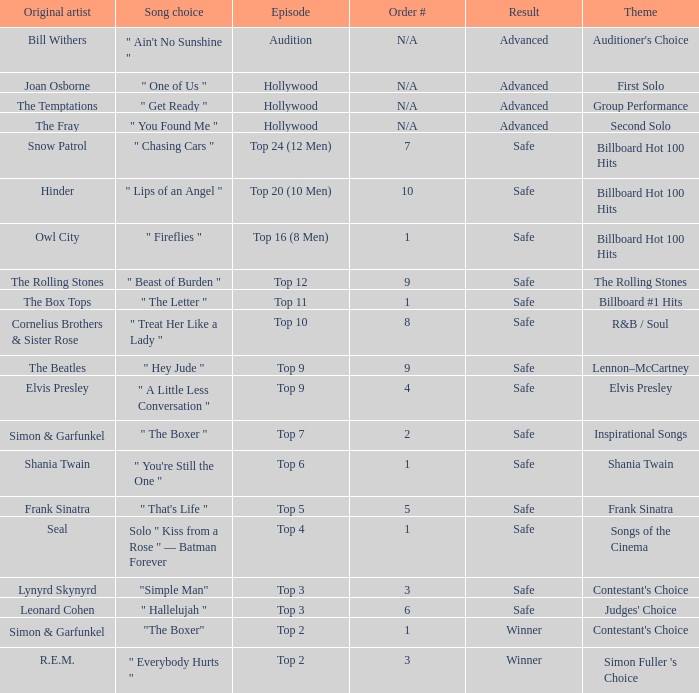The theme Auditioner's Choice	has what song choice? " Ain't No Sunshine ". 